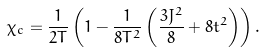Convert formula to latex. <formula><loc_0><loc_0><loc_500><loc_500>\chi _ { c } = \frac { 1 } { 2 T } \left ( 1 - \frac { 1 } { 8 T ^ { 2 } } \left ( \frac { 3 J ^ { 2 } } { 8 } + 8 t ^ { 2 } \right ) \right ) .</formula> 